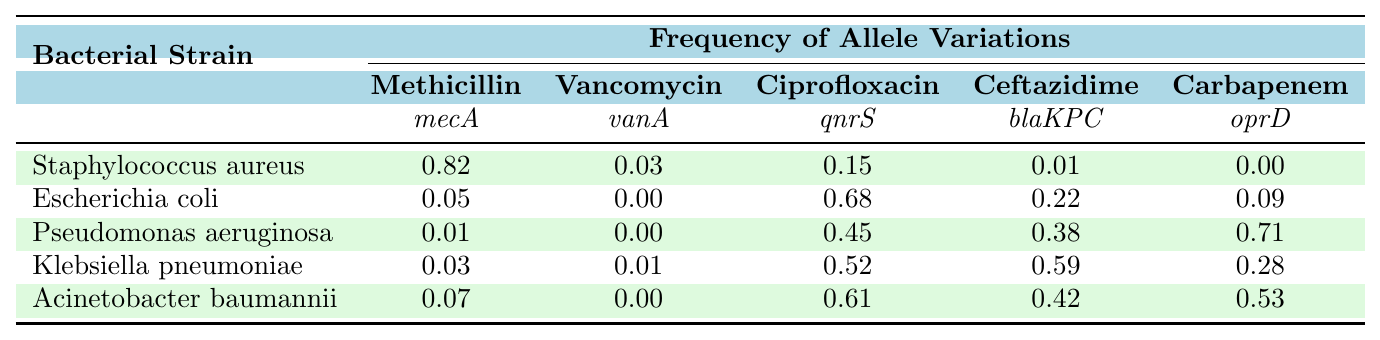What is the frequency of the mecA allele variation in Staphylococcus aureus? The table shows that the frequency of the mecA allele variation for Staphylococcus aureus is 0.82.
Answer: 0.82 Which bacterial strain has the highest frequency of the qnrS allele? Looking at the table, Escherichia coli has the highest frequency of the qnrS allele at 0.68, compared to the other strains.
Answer: Escherichia coli Is the frequency of the vanA allele in Acinetobacter baumannii zero? According to the table, the frequency of the vanA allele in Acinetobacter baumannii is listed as 0.00, confirming it is indeed zero.
Answer: Yes What is the average frequency of the blaKPC allele across all strains? To find the average, we sum the frequencies of blaKPC: 0.01 + 0.22 + 0.38 + 0.59 + 0.42 = 1.62. There are 5 strains, so the average is 1.62/5 = 0.324.
Answer: 0.324 Which strain has the lowest frequency for the carbapenem oprD allele? The lowest frequency for the oprD allele is found in Staphylococcus aureus, which is 0.00; by comparing the frequencies listed, it is clear.
Answer: Staphylococcus aureus If we exclude the lowest values, what is the comparison between the highest frequency of the mecA allele and the average frequency of the qnrS allele? The highest frequency of mecA is 0.82 (Staphylococcus aureus). The average frequency of qnrS is (0.15 + 0.68 + 0.45 + 0.52 + 0.61)/5 = 0.482. Comparing the two: 0.82 > 0.482.
Answer: mecA is higher Is there a strain with more than 0.5 frequency for both qnrS and blaKPC alleles? By checking the table, Pseudomonas aeruginosa has 0.45 for qnrS and 0.38 for blaKPC, while Klebsiella pneumoniae has 0.52 for qnrS and 0.59 for blaKPC. Therefore, no strain meets the criteria for both.
Answer: No What is the total frequency of mecA across all strains? Summing the frequencies for mecA: 0.82 + 0.05 + 0.01 + 0.03 + 0.07 = 0.98.
Answer: 0.98 